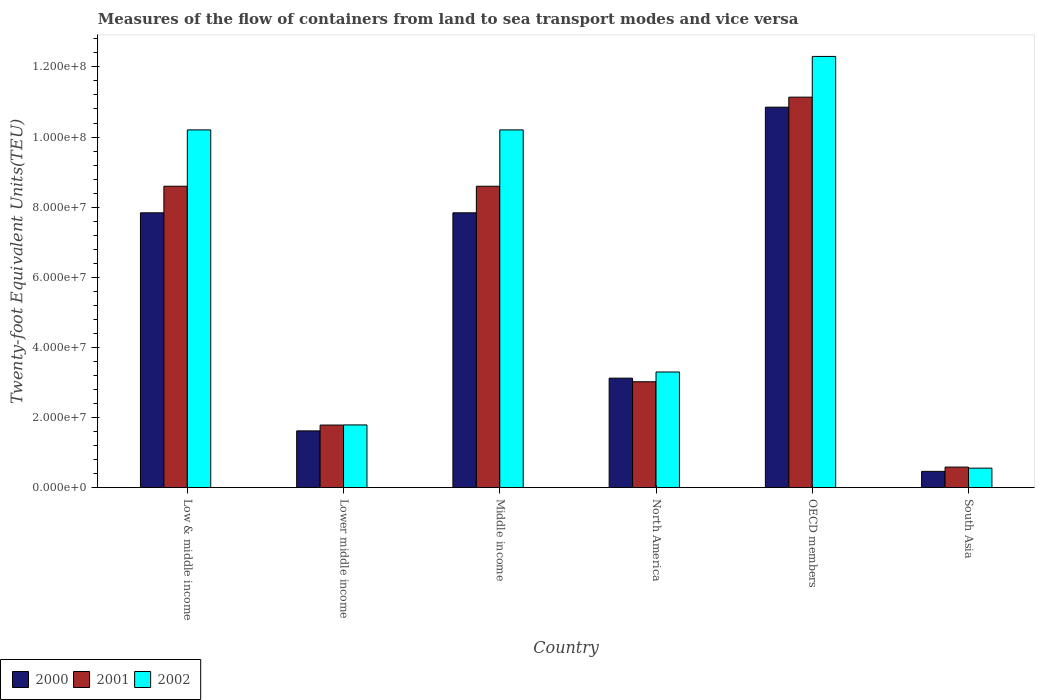How many different coloured bars are there?
Your answer should be very brief. 3. Are the number of bars per tick equal to the number of legend labels?
Keep it short and to the point. Yes. How many bars are there on the 6th tick from the right?
Keep it short and to the point. 3. What is the label of the 3rd group of bars from the left?
Make the answer very short. Middle income. In how many cases, is the number of bars for a given country not equal to the number of legend labels?
Provide a short and direct response. 0. What is the container port traffic in 2001 in Lower middle income?
Make the answer very short. 1.78e+07. Across all countries, what is the maximum container port traffic in 2002?
Your answer should be compact. 1.23e+08. Across all countries, what is the minimum container port traffic in 2000?
Offer a very short reply. 4.64e+06. What is the total container port traffic in 2000 in the graph?
Give a very brief answer. 3.17e+08. What is the difference between the container port traffic in 2000 in Low & middle income and that in Lower middle income?
Give a very brief answer. 6.22e+07. What is the difference between the container port traffic in 2001 in OECD members and the container port traffic in 2002 in North America?
Provide a short and direct response. 7.84e+07. What is the average container port traffic in 2000 per country?
Offer a very short reply. 5.29e+07. What is the difference between the container port traffic of/in 2000 and container port traffic of/in 2001 in Lower middle income?
Keep it short and to the point. -1.66e+06. What is the ratio of the container port traffic in 2000 in Low & middle income to that in Lower middle income?
Give a very brief answer. 4.84. Is the container port traffic in 2001 in Lower middle income less than that in South Asia?
Offer a terse response. No. Is the difference between the container port traffic in 2000 in North America and South Asia greater than the difference between the container port traffic in 2001 in North America and South Asia?
Make the answer very short. Yes. What is the difference between the highest and the second highest container port traffic in 2000?
Offer a very short reply. 3.01e+07. What is the difference between the highest and the lowest container port traffic in 2001?
Offer a very short reply. 1.06e+08. In how many countries, is the container port traffic in 2001 greater than the average container port traffic in 2001 taken over all countries?
Your answer should be very brief. 3. Is the sum of the container port traffic in 2001 in Middle income and North America greater than the maximum container port traffic in 2000 across all countries?
Give a very brief answer. Yes. How many bars are there?
Make the answer very short. 18. Are all the bars in the graph horizontal?
Your answer should be very brief. No. Does the graph contain grids?
Give a very brief answer. No. How many legend labels are there?
Make the answer very short. 3. What is the title of the graph?
Make the answer very short. Measures of the flow of containers from land to sea transport modes and vice versa. What is the label or title of the Y-axis?
Ensure brevity in your answer.  Twenty-foot Equivalent Units(TEU). What is the Twenty-foot Equivalent Units(TEU) in 2000 in Low & middle income?
Make the answer very short. 7.84e+07. What is the Twenty-foot Equivalent Units(TEU) of 2001 in Low & middle income?
Provide a succinct answer. 8.60e+07. What is the Twenty-foot Equivalent Units(TEU) of 2002 in Low & middle income?
Ensure brevity in your answer.  1.02e+08. What is the Twenty-foot Equivalent Units(TEU) of 2000 in Lower middle income?
Offer a terse response. 1.62e+07. What is the Twenty-foot Equivalent Units(TEU) of 2001 in Lower middle income?
Make the answer very short. 1.78e+07. What is the Twenty-foot Equivalent Units(TEU) of 2002 in Lower middle income?
Offer a very short reply. 1.79e+07. What is the Twenty-foot Equivalent Units(TEU) of 2000 in Middle income?
Provide a succinct answer. 7.84e+07. What is the Twenty-foot Equivalent Units(TEU) of 2001 in Middle income?
Provide a short and direct response. 8.60e+07. What is the Twenty-foot Equivalent Units(TEU) in 2002 in Middle income?
Make the answer very short. 1.02e+08. What is the Twenty-foot Equivalent Units(TEU) of 2000 in North America?
Provide a succinct answer. 3.12e+07. What is the Twenty-foot Equivalent Units(TEU) in 2001 in North America?
Make the answer very short. 3.02e+07. What is the Twenty-foot Equivalent Units(TEU) in 2002 in North America?
Offer a terse response. 3.30e+07. What is the Twenty-foot Equivalent Units(TEU) of 2000 in OECD members?
Offer a very short reply. 1.09e+08. What is the Twenty-foot Equivalent Units(TEU) in 2001 in OECD members?
Make the answer very short. 1.11e+08. What is the Twenty-foot Equivalent Units(TEU) of 2002 in OECD members?
Make the answer very short. 1.23e+08. What is the Twenty-foot Equivalent Units(TEU) of 2000 in South Asia?
Give a very brief answer. 4.64e+06. What is the Twenty-foot Equivalent Units(TEU) of 2001 in South Asia?
Make the answer very short. 5.86e+06. What is the Twenty-foot Equivalent Units(TEU) in 2002 in South Asia?
Give a very brief answer. 5.56e+06. Across all countries, what is the maximum Twenty-foot Equivalent Units(TEU) of 2000?
Give a very brief answer. 1.09e+08. Across all countries, what is the maximum Twenty-foot Equivalent Units(TEU) of 2001?
Provide a succinct answer. 1.11e+08. Across all countries, what is the maximum Twenty-foot Equivalent Units(TEU) of 2002?
Your answer should be very brief. 1.23e+08. Across all countries, what is the minimum Twenty-foot Equivalent Units(TEU) of 2000?
Make the answer very short. 4.64e+06. Across all countries, what is the minimum Twenty-foot Equivalent Units(TEU) of 2001?
Offer a terse response. 5.86e+06. Across all countries, what is the minimum Twenty-foot Equivalent Units(TEU) of 2002?
Provide a short and direct response. 5.56e+06. What is the total Twenty-foot Equivalent Units(TEU) of 2000 in the graph?
Offer a terse response. 3.17e+08. What is the total Twenty-foot Equivalent Units(TEU) in 2001 in the graph?
Make the answer very short. 3.37e+08. What is the total Twenty-foot Equivalent Units(TEU) in 2002 in the graph?
Offer a very short reply. 3.83e+08. What is the difference between the Twenty-foot Equivalent Units(TEU) in 2000 in Low & middle income and that in Lower middle income?
Ensure brevity in your answer.  6.22e+07. What is the difference between the Twenty-foot Equivalent Units(TEU) of 2001 in Low & middle income and that in Lower middle income?
Make the answer very short. 6.81e+07. What is the difference between the Twenty-foot Equivalent Units(TEU) of 2002 in Low & middle income and that in Lower middle income?
Provide a succinct answer. 8.42e+07. What is the difference between the Twenty-foot Equivalent Units(TEU) in 2000 in Low & middle income and that in North America?
Provide a succinct answer. 4.72e+07. What is the difference between the Twenty-foot Equivalent Units(TEU) in 2001 in Low & middle income and that in North America?
Keep it short and to the point. 5.58e+07. What is the difference between the Twenty-foot Equivalent Units(TEU) in 2002 in Low & middle income and that in North America?
Your answer should be compact. 6.91e+07. What is the difference between the Twenty-foot Equivalent Units(TEU) in 2000 in Low & middle income and that in OECD members?
Provide a succinct answer. -3.01e+07. What is the difference between the Twenty-foot Equivalent Units(TEU) of 2001 in Low & middle income and that in OECD members?
Your answer should be compact. -2.54e+07. What is the difference between the Twenty-foot Equivalent Units(TEU) of 2002 in Low & middle income and that in OECD members?
Your response must be concise. -2.10e+07. What is the difference between the Twenty-foot Equivalent Units(TEU) in 2000 in Low & middle income and that in South Asia?
Provide a short and direct response. 7.37e+07. What is the difference between the Twenty-foot Equivalent Units(TEU) in 2001 in Low & middle income and that in South Asia?
Offer a terse response. 8.01e+07. What is the difference between the Twenty-foot Equivalent Units(TEU) in 2002 in Low & middle income and that in South Asia?
Make the answer very short. 9.65e+07. What is the difference between the Twenty-foot Equivalent Units(TEU) in 2000 in Lower middle income and that in Middle income?
Make the answer very short. -6.22e+07. What is the difference between the Twenty-foot Equivalent Units(TEU) of 2001 in Lower middle income and that in Middle income?
Give a very brief answer. -6.81e+07. What is the difference between the Twenty-foot Equivalent Units(TEU) in 2002 in Lower middle income and that in Middle income?
Your response must be concise. -8.42e+07. What is the difference between the Twenty-foot Equivalent Units(TEU) of 2000 in Lower middle income and that in North America?
Give a very brief answer. -1.50e+07. What is the difference between the Twenty-foot Equivalent Units(TEU) of 2001 in Lower middle income and that in North America?
Provide a succinct answer. -1.24e+07. What is the difference between the Twenty-foot Equivalent Units(TEU) of 2002 in Lower middle income and that in North America?
Give a very brief answer. -1.51e+07. What is the difference between the Twenty-foot Equivalent Units(TEU) of 2000 in Lower middle income and that in OECD members?
Give a very brief answer. -9.23e+07. What is the difference between the Twenty-foot Equivalent Units(TEU) of 2001 in Lower middle income and that in OECD members?
Keep it short and to the point. -9.35e+07. What is the difference between the Twenty-foot Equivalent Units(TEU) of 2002 in Lower middle income and that in OECD members?
Give a very brief answer. -1.05e+08. What is the difference between the Twenty-foot Equivalent Units(TEU) in 2000 in Lower middle income and that in South Asia?
Ensure brevity in your answer.  1.15e+07. What is the difference between the Twenty-foot Equivalent Units(TEU) of 2001 in Lower middle income and that in South Asia?
Make the answer very short. 1.20e+07. What is the difference between the Twenty-foot Equivalent Units(TEU) of 2002 in Lower middle income and that in South Asia?
Your response must be concise. 1.23e+07. What is the difference between the Twenty-foot Equivalent Units(TEU) in 2000 in Middle income and that in North America?
Your answer should be very brief. 4.72e+07. What is the difference between the Twenty-foot Equivalent Units(TEU) in 2001 in Middle income and that in North America?
Offer a terse response. 5.58e+07. What is the difference between the Twenty-foot Equivalent Units(TEU) of 2002 in Middle income and that in North America?
Make the answer very short. 6.91e+07. What is the difference between the Twenty-foot Equivalent Units(TEU) of 2000 in Middle income and that in OECD members?
Make the answer very short. -3.01e+07. What is the difference between the Twenty-foot Equivalent Units(TEU) of 2001 in Middle income and that in OECD members?
Offer a very short reply. -2.54e+07. What is the difference between the Twenty-foot Equivalent Units(TEU) in 2002 in Middle income and that in OECD members?
Ensure brevity in your answer.  -2.10e+07. What is the difference between the Twenty-foot Equivalent Units(TEU) of 2000 in Middle income and that in South Asia?
Ensure brevity in your answer.  7.37e+07. What is the difference between the Twenty-foot Equivalent Units(TEU) of 2001 in Middle income and that in South Asia?
Offer a very short reply. 8.01e+07. What is the difference between the Twenty-foot Equivalent Units(TEU) of 2002 in Middle income and that in South Asia?
Ensure brevity in your answer.  9.65e+07. What is the difference between the Twenty-foot Equivalent Units(TEU) of 2000 in North America and that in OECD members?
Give a very brief answer. -7.73e+07. What is the difference between the Twenty-foot Equivalent Units(TEU) of 2001 in North America and that in OECD members?
Offer a terse response. -8.12e+07. What is the difference between the Twenty-foot Equivalent Units(TEU) in 2002 in North America and that in OECD members?
Ensure brevity in your answer.  -9.00e+07. What is the difference between the Twenty-foot Equivalent Units(TEU) of 2000 in North America and that in South Asia?
Provide a short and direct response. 2.66e+07. What is the difference between the Twenty-foot Equivalent Units(TEU) of 2001 in North America and that in South Asia?
Offer a very short reply. 2.43e+07. What is the difference between the Twenty-foot Equivalent Units(TEU) in 2002 in North America and that in South Asia?
Give a very brief answer. 2.74e+07. What is the difference between the Twenty-foot Equivalent Units(TEU) in 2000 in OECD members and that in South Asia?
Your response must be concise. 1.04e+08. What is the difference between the Twenty-foot Equivalent Units(TEU) in 2001 in OECD members and that in South Asia?
Your answer should be very brief. 1.06e+08. What is the difference between the Twenty-foot Equivalent Units(TEU) in 2002 in OECD members and that in South Asia?
Give a very brief answer. 1.17e+08. What is the difference between the Twenty-foot Equivalent Units(TEU) of 2000 in Low & middle income and the Twenty-foot Equivalent Units(TEU) of 2001 in Lower middle income?
Your response must be concise. 6.05e+07. What is the difference between the Twenty-foot Equivalent Units(TEU) of 2000 in Low & middle income and the Twenty-foot Equivalent Units(TEU) of 2002 in Lower middle income?
Your answer should be very brief. 6.05e+07. What is the difference between the Twenty-foot Equivalent Units(TEU) in 2001 in Low & middle income and the Twenty-foot Equivalent Units(TEU) in 2002 in Lower middle income?
Make the answer very short. 6.81e+07. What is the difference between the Twenty-foot Equivalent Units(TEU) of 2000 in Low & middle income and the Twenty-foot Equivalent Units(TEU) of 2001 in Middle income?
Offer a terse response. -7.58e+06. What is the difference between the Twenty-foot Equivalent Units(TEU) of 2000 in Low & middle income and the Twenty-foot Equivalent Units(TEU) of 2002 in Middle income?
Make the answer very short. -2.37e+07. What is the difference between the Twenty-foot Equivalent Units(TEU) in 2001 in Low & middle income and the Twenty-foot Equivalent Units(TEU) in 2002 in Middle income?
Your response must be concise. -1.61e+07. What is the difference between the Twenty-foot Equivalent Units(TEU) in 2000 in Low & middle income and the Twenty-foot Equivalent Units(TEU) in 2001 in North America?
Give a very brief answer. 4.82e+07. What is the difference between the Twenty-foot Equivalent Units(TEU) of 2000 in Low & middle income and the Twenty-foot Equivalent Units(TEU) of 2002 in North America?
Offer a terse response. 4.54e+07. What is the difference between the Twenty-foot Equivalent Units(TEU) in 2001 in Low & middle income and the Twenty-foot Equivalent Units(TEU) in 2002 in North America?
Your answer should be very brief. 5.30e+07. What is the difference between the Twenty-foot Equivalent Units(TEU) in 2000 in Low & middle income and the Twenty-foot Equivalent Units(TEU) in 2001 in OECD members?
Provide a short and direct response. -3.30e+07. What is the difference between the Twenty-foot Equivalent Units(TEU) in 2000 in Low & middle income and the Twenty-foot Equivalent Units(TEU) in 2002 in OECD members?
Ensure brevity in your answer.  -4.46e+07. What is the difference between the Twenty-foot Equivalent Units(TEU) of 2001 in Low & middle income and the Twenty-foot Equivalent Units(TEU) of 2002 in OECD members?
Offer a very short reply. -3.70e+07. What is the difference between the Twenty-foot Equivalent Units(TEU) of 2000 in Low & middle income and the Twenty-foot Equivalent Units(TEU) of 2001 in South Asia?
Give a very brief answer. 7.25e+07. What is the difference between the Twenty-foot Equivalent Units(TEU) in 2000 in Low & middle income and the Twenty-foot Equivalent Units(TEU) in 2002 in South Asia?
Your answer should be compact. 7.28e+07. What is the difference between the Twenty-foot Equivalent Units(TEU) of 2001 in Low & middle income and the Twenty-foot Equivalent Units(TEU) of 2002 in South Asia?
Keep it short and to the point. 8.04e+07. What is the difference between the Twenty-foot Equivalent Units(TEU) in 2000 in Lower middle income and the Twenty-foot Equivalent Units(TEU) in 2001 in Middle income?
Your answer should be very brief. -6.98e+07. What is the difference between the Twenty-foot Equivalent Units(TEU) of 2000 in Lower middle income and the Twenty-foot Equivalent Units(TEU) of 2002 in Middle income?
Provide a succinct answer. -8.59e+07. What is the difference between the Twenty-foot Equivalent Units(TEU) in 2001 in Lower middle income and the Twenty-foot Equivalent Units(TEU) in 2002 in Middle income?
Your answer should be compact. -8.42e+07. What is the difference between the Twenty-foot Equivalent Units(TEU) of 2000 in Lower middle income and the Twenty-foot Equivalent Units(TEU) of 2001 in North America?
Offer a very short reply. -1.40e+07. What is the difference between the Twenty-foot Equivalent Units(TEU) of 2000 in Lower middle income and the Twenty-foot Equivalent Units(TEU) of 2002 in North America?
Your answer should be compact. -1.68e+07. What is the difference between the Twenty-foot Equivalent Units(TEU) in 2001 in Lower middle income and the Twenty-foot Equivalent Units(TEU) in 2002 in North America?
Offer a very short reply. -1.51e+07. What is the difference between the Twenty-foot Equivalent Units(TEU) of 2000 in Lower middle income and the Twenty-foot Equivalent Units(TEU) of 2001 in OECD members?
Offer a terse response. -9.52e+07. What is the difference between the Twenty-foot Equivalent Units(TEU) in 2000 in Lower middle income and the Twenty-foot Equivalent Units(TEU) in 2002 in OECD members?
Give a very brief answer. -1.07e+08. What is the difference between the Twenty-foot Equivalent Units(TEU) of 2001 in Lower middle income and the Twenty-foot Equivalent Units(TEU) of 2002 in OECD members?
Your answer should be very brief. -1.05e+08. What is the difference between the Twenty-foot Equivalent Units(TEU) of 2000 in Lower middle income and the Twenty-foot Equivalent Units(TEU) of 2001 in South Asia?
Provide a succinct answer. 1.03e+07. What is the difference between the Twenty-foot Equivalent Units(TEU) in 2000 in Lower middle income and the Twenty-foot Equivalent Units(TEU) in 2002 in South Asia?
Ensure brevity in your answer.  1.06e+07. What is the difference between the Twenty-foot Equivalent Units(TEU) in 2001 in Lower middle income and the Twenty-foot Equivalent Units(TEU) in 2002 in South Asia?
Your response must be concise. 1.23e+07. What is the difference between the Twenty-foot Equivalent Units(TEU) in 2000 in Middle income and the Twenty-foot Equivalent Units(TEU) in 2001 in North America?
Your answer should be compact. 4.82e+07. What is the difference between the Twenty-foot Equivalent Units(TEU) of 2000 in Middle income and the Twenty-foot Equivalent Units(TEU) of 2002 in North America?
Your answer should be compact. 4.54e+07. What is the difference between the Twenty-foot Equivalent Units(TEU) in 2001 in Middle income and the Twenty-foot Equivalent Units(TEU) in 2002 in North America?
Provide a succinct answer. 5.30e+07. What is the difference between the Twenty-foot Equivalent Units(TEU) in 2000 in Middle income and the Twenty-foot Equivalent Units(TEU) in 2001 in OECD members?
Your answer should be compact. -3.30e+07. What is the difference between the Twenty-foot Equivalent Units(TEU) of 2000 in Middle income and the Twenty-foot Equivalent Units(TEU) of 2002 in OECD members?
Your answer should be compact. -4.46e+07. What is the difference between the Twenty-foot Equivalent Units(TEU) of 2001 in Middle income and the Twenty-foot Equivalent Units(TEU) of 2002 in OECD members?
Keep it short and to the point. -3.70e+07. What is the difference between the Twenty-foot Equivalent Units(TEU) of 2000 in Middle income and the Twenty-foot Equivalent Units(TEU) of 2001 in South Asia?
Make the answer very short. 7.25e+07. What is the difference between the Twenty-foot Equivalent Units(TEU) in 2000 in Middle income and the Twenty-foot Equivalent Units(TEU) in 2002 in South Asia?
Make the answer very short. 7.28e+07. What is the difference between the Twenty-foot Equivalent Units(TEU) in 2001 in Middle income and the Twenty-foot Equivalent Units(TEU) in 2002 in South Asia?
Give a very brief answer. 8.04e+07. What is the difference between the Twenty-foot Equivalent Units(TEU) of 2000 in North America and the Twenty-foot Equivalent Units(TEU) of 2001 in OECD members?
Offer a terse response. -8.01e+07. What is the difference between the Twenty-foot Equivalent Units(TEU) in 2000 in North America and the Twenty-foot Equivalent Units(TEU) in 2002 in OECD members?
Offer a terse response. -9.18e+07. What is the difference between the Twenty-foot Equivalent Units(TEU) of 2001 in North America and the Twenty-foot Equivalent Units(TEU) of 2002 in OECD members?
Offer a very short reply. -9.28e+07. What is the difference between the Twenty-foot Equivalent Units(TEU) in 2000 in North America and the Twenty-foot Equivalent Units(TEU) in 2001 in South Asia?
Ensure brevity in your answer.  2.54e+07. What is the difference between the Twenty-foot Equivalent Units(TEU) of 2000 in North America and the Twenty-foot Equivalent Units(TEU) of 2002 in South Asia?
Your response must be concise. 2.57e+07. What is the difference between the Twenty-foot Equivalent Units(TEU) of 2001 in North America and the Twenty-foot Equivalent Units(TEU) of 2002 in South Asia?
Offer a very short reply. 2.46e+07. What is the difference between the Twenty-foot Equivalent Units(TEU) of 2000 in OECD members and the Twenty-foot Equivalent Units(TEU) of 2001 in South Asia?
Give a very brief answer. 1.03e+08. What is the difference between the Twenty-foot Equivalent Units(TEU) of 2000 in OECD members and the Twenty-foot Equivalent Units(TEU) of 2002 in South Asia?
Make the answer very short. 1.03e+08. What is the difference between the Twenty-foot Equivalent Units(TEU) of 2001 in OECD members and the Twenty-foot Equivalent Units(TEU) of 2002 in South Asia?
Offer a terse response. 1.06e+08. What is the average Twenty-foot Equivalent Units(TEU) in 2000 per country?
Your answer should be compact. 5.29e+07. What is the average Twenty-foot Equivalent Units(TEU) in 2001 per country?
Your answer should be very brief. 5.62e+07. What is the average Twenty-foot Equivalent Units(TEU) of 2002 per country?
Make the answer very short. 6.39e+07. What is the difference between the Twenty-foot Equivalent Units(TEU) in 2000 and Twenty-foot Equivalent Units(TEU) in 2001 in Low & middle income?
Your answer should be compact. -7.58e+06. What is the difference between the Twenty-foot Equivalent Units(TEU) of 2000 and Twenty-foot Equivalent Units(TEU) of 2002 in Low & middle income?
Give a very brief answer. -2.37e+07. What is the difference between the Twenty-foot Equivalent Units(TEU) of 2001 and Twenty-foot Equivalent Units(TEU) of 2002 in Low & middle income?
Your response must be concise. -1.61e+07. What is the difference between the Twenty-foot Equivalent Units(TEU) of 2000 and Twenty-foot Equivalent Units(TEU) of 2001 in Lower middle income?
Offer a terse response. -1.66e+06. What is the difference between the Twenty-foot Equivalent Units(TEU) of 2000 and Twenty-foot Equivalent Units(TEU) of 2002 in Lower middle income?
Offer a terse response. -1.70e+06. What is the difference between the Twenty-foot Equivalent Units(TEU) of 2001 and Twenty-foot Equivalent Units(TEU) of 2002 in Lower middle income?
Your answer should be very brief. -3.79e+04. What is the difference between the Twenty-foot Equivalent Units(TEU) in 2000 and Twenty-foot Equivalent Units(TEU) in 2001 in Middle income?
Provide a short and direct response. -7.58e+06. What is the difference between the Twenty-foot Equivalent Units(TEU) of 2000 and Twenty-foot Equivalent Units(TEU) of 2002 in Middle income?
Give a very brief answer. -2.37e+07. What is the difference between the Twenty-foot Equivalent Units(TEU) in 2001 and Twenty-foot Equivalent Units(TEU) in 2002 in Middle income?
Provide a short and direct response. -1.61e+07. What is the difference between the Twenty-foot Equivalent Units(TEU) in 2000 and Twenty-foot Equivalent Units(TEU) in 2001 in North America?
Ensure brevity in your answer.  1.03e+06. What is the difference between the Twenty-foot Equivalent Units(TEU) of 2000 and Twenty-foot Equivalent Units(TEU) of 2002 in North America?
Keep it short and to the point. -1.76e+06. What is the difference between the Twenty-foot Equivalent Units(TEU) of 2001 and Twenty-foot Equivalent Units(TEU) of 2002 in North America?
Your response must be concise. -2.79e+06. What is the difference between the Twenty-foot Equivalent Units(TEU) in 2000 and Twenty-foot Equivalent Units(TEU) in 2001 in OECD members?
Provide a short and direct response. -2.86e+06. What is the difference between the Twenty-foot Equivalent Units(TEU) in 2000 and Twenty-foot Equivalent Units(TEU) in 2002 in OECD members?
Give a very brief answer. -1.45e+07. What is the difference between the Twenty-foot Equivalent Units(TEU) of 2001 and Twenty-foot Equivalent Units(TEU) of 2002 in OECD members?
Your response must be concise. -1.16e+07. What is the difference between the Twenty-foot Equivalent Units(TEU) of 2000 and Twenty-foot Equivalent Units(TEU) of 2001 in South Asia?
Provide a succinct answer. -1.22e+06. What is the difference between the Twenty-foot Equivalent Units(TEU) in 2000 and Twenty-foot Equivalent Units(TEU) in 2002 in South Asia?
Ensure brevity in your answer.  -9.18e+05. What is the difference between the Twenty-foot Equivalent Units(TEU) in 2001 and Twenty-foot Equivalent Units(TEU) in 2002 in South Asia?
Make the answer very short. 2.99e+05. What is the ratio of the Twenty-foot Equivalent Units(TEU) in 2000 in Low & middle income to that in Lower middle income?
Make the answer very short. 4.84. What is the ratio of the Twenty-foot Equivalent Units(TEU) of 2001 in Low & middle income to that in Lower middle income?
Your response must be concise. 4.82. What is the ratio of the Twenty-foot Equivalent Units(TEU) in 2002 in Low & middle income to that in Lower middle income?
Keep it short and to the point. 5.71. What is the ratio of the Twenty-foot Equivalent Units(TEU) of 2002 in Low & middle income to that in Middle income?
Give a very brief answer. 1. What is the ratio of the Twenty-foot Equivalent Units(TEU) of 2000 in Low & middle income to that in North America?
Your answer should be very brief. 2.51. What is the ratio of the Twenty-foot Equivalent Units(TEU) of 2001 in Low & middle income to that in North America?
Offer a terse response. 2.85. What is the ratio of the Twenty-foot Equivalent Units(TEU) of 2002 in Low & middle income to that in North America?
Offer a terse response. 3.09. What is the ratio of the Twenty-foot Equivalent Units(TEU) of 2000 in Low & middle income to that in OECD members?
Your answer should be very brief. 0.72. What is the ratio of the Twenty-foot Equivalent Units(TEU) of 2001 in Low & middle income to that in OECD members?
Offer a very short reply. 0.77. What is the ratio of the Twenty-foot Equivalent Units(TEU) of 2002 in Low & middle income to that in OECD members?
Your response must be concise. 0.83. What is the ratio of the Twenty-foot Equivalent Units(TEU) of 2000 in Low & middle income to that in South Asia?
Offer a terse response. 16.89. What is the ratio of the Twenty-foot Equivalent Units(TEU) of 2001 in Low & middle income to that in South Asia?
Make the answer very short. 14.68. What is the ratio of the Twenty-foot Equivalent Units(TEU) in 2002 in Low & middle income to that in South Asia?
Provide a short and direct response. 18.36. What is the ratio of the Twenty-foot Equivalent Units(TEU) in 2000 in Lower middle income to that in Middle income?
Your response must be concise. 0.21. What is the ratio of the Twenty-foot Equivalent Units(TEU) of 2001 in Lower middle income to that in Middle income?
Your answer should be compact. 0.21. What is the ratio of the Twenty-foot Equivalent Units(TEU) in 2002 in Lower middle income to that in Middle income?
Offer a terse response. 0.18. What is the ratio of the Twenty-foot Equivalent Units(TEU) of 2000 in Lower middle income to that in North America?
Your response must be concise. 0.52. What is the ratio of the Twenty-foot Equivalent Units(TEU) in 2001 in Lower middle income to that in North America?
Ensure brevity in your answer.  0.59. What is the ratio of the Twenty-foot Equivalent Units(TEU) in 2002 in Lower middle income to that in North America?
Offer a terse response. 0.54. What is the ratio of the Twenty-foot Equivalent Units(TEU) of 2000 in Lower middle income to that in OECD members?
Your answer should be compact. 0.15. What is the ratio of the Twenty-foot Equivalent Units(TEU) in 2001 in Lower middle income to that in OECD members?
Make the answer very short. 0.16. What is the ratio of the Twenty-foot Equivalent Units(TEU) in 2002 in Lower middle income to that in OECD members?
Your response must be concise. 0.15. What is the ratio of the Twenty-foot Equivalent Units(TEU) of 2000 in Lower middle income to that in South Asia?
Your response must be concise. 3.49. What is the ratio of the Twenty-foot Equivalent Units(TEU) in 2001 in Lower middle income to that in South Asia?
Offer a very short reply. 3.05. What is the ratio of the Twenty-foot Equivalent Units(TEU) in 2002 in Lower middle income to that in South Asia?
Keep it short and to the point. 3.22. What is the ratio of the Twenty-foot Equivalent Units(TEU) in 2000 in Middle income to that in North America?
Your response must be concise. 2.51. What is the ratio of the Twenty-foot Equivalent Units(TEU) in 2001 in Middle income to that in North America?
Provide a succinct answer. 2.85. What is the ratio of the Twenty-foot Equivalent Units(TEU) of 2002 in Middle income to that in North America?
Provide a succinct answer. 3.09. What is the ratio of the Twenty-foot Equivalent Units(TEU) of 2000 in Middle income to that in OECD members?
Make the answer very short. 0.72. What is the ratio of the Twenty-foot Equivalent Units(TEU) in 2001 in Middle income to that in OECD members?
Your response must be concise. 0.77. What is the ratio of the Twenty-foot Equivalent Units(TEU) in 2002 in Middle income to that in OECD members?
Offer a very short reply. 0.83. What is the ratio of the Twenty-foot Equivalent Units(TEU) in 2000 in Middle income to that in South Asia?
Offer a terse response. 16.89. What is the ratio of the Twenty-foot Equivalent Units(TEU) in 2001 in Middle income to that in South Asia?
Your answer should be compact. 14.68. What is the ratio of the Twenty-foot Equivalent Units(TEU) of 2002 in Middle income to that in South Asia?
Keep it short and to the point. 18.36. What is the ratio of the Twenty-foot Equivalent Units(TEU) of 2000 in North America to that in OECD members?
Keep it short and to the point. 0.29. What is the ratio of the Twenty-foot Equivalent Units(TEU) in 2001 in North America to that in OECD members?
Offer a very short reply. 0.27. What is the ratio of the Twenty-foot Equivalent Units(TEU) in 2002 in North America to that in OECD members?
Provide a succinct answer. 0.27. What is the ratio of the Twenty-foot Equivalent Units(TEU) in 2000 in North America to that in South Asia?
Make the answer very short. 6.73. What is the ratio of the Twenty-foot Equivalent Units(TEU) of 2001 in North America to that in South Asia?
Your answer should be compact. 5.16. What is the ratio of the Twenty-foot Equivalent Units(TEU) in 2002 in North America to that in South Asia?
Provide a succinct answer. 5.94. What is the ratio of the Twenty-foot Equivalent Units(TEU) of 2000 in OECD members to that in South Asia?
Ensure brevity in your answer.  23.39. What is the ratio of the Twenty-foot Equivalent Units(TEU) in 2001 in OECD members to that in South Asia?
Make the answer very short. 19.02. What is the ratio of the Twenty-foot Equivalent Units(TEU) of 2002 in OECD members to that in South Asia?
Provide a short and direct response. 22.13. What is the difference between the highest and the second highest Twenty-foot Equivalent Units(TEU) of 2000?
Your answer should be very brief. 3.01e+07. What is the difference between the highest and the second highest Twenty-foot Equivalent Units(TEU) of 2001?
Keep it short and to the point. 2.54e+07. What is the difference between the highest and the second highest Twenty-foot Equivalent Units(TEU) of 2002?
Your response must be concise. 2.10e+07. What is the difference between the highest and the lowest Twenty-foot Equivalent Units(TEU) of 2000?
Give a very brief answer. 1.04e+08. What is the difference between the highest and the lowest Twenty-foot Equivalent Units(TEU) in 2001?
Make the answer very short. 1.06e+08. What is the difference between the highest and the lowest Twenty-foot Equivalent Units(TEU) of 2002?
Your answer should be compact. 1.17e+08. 